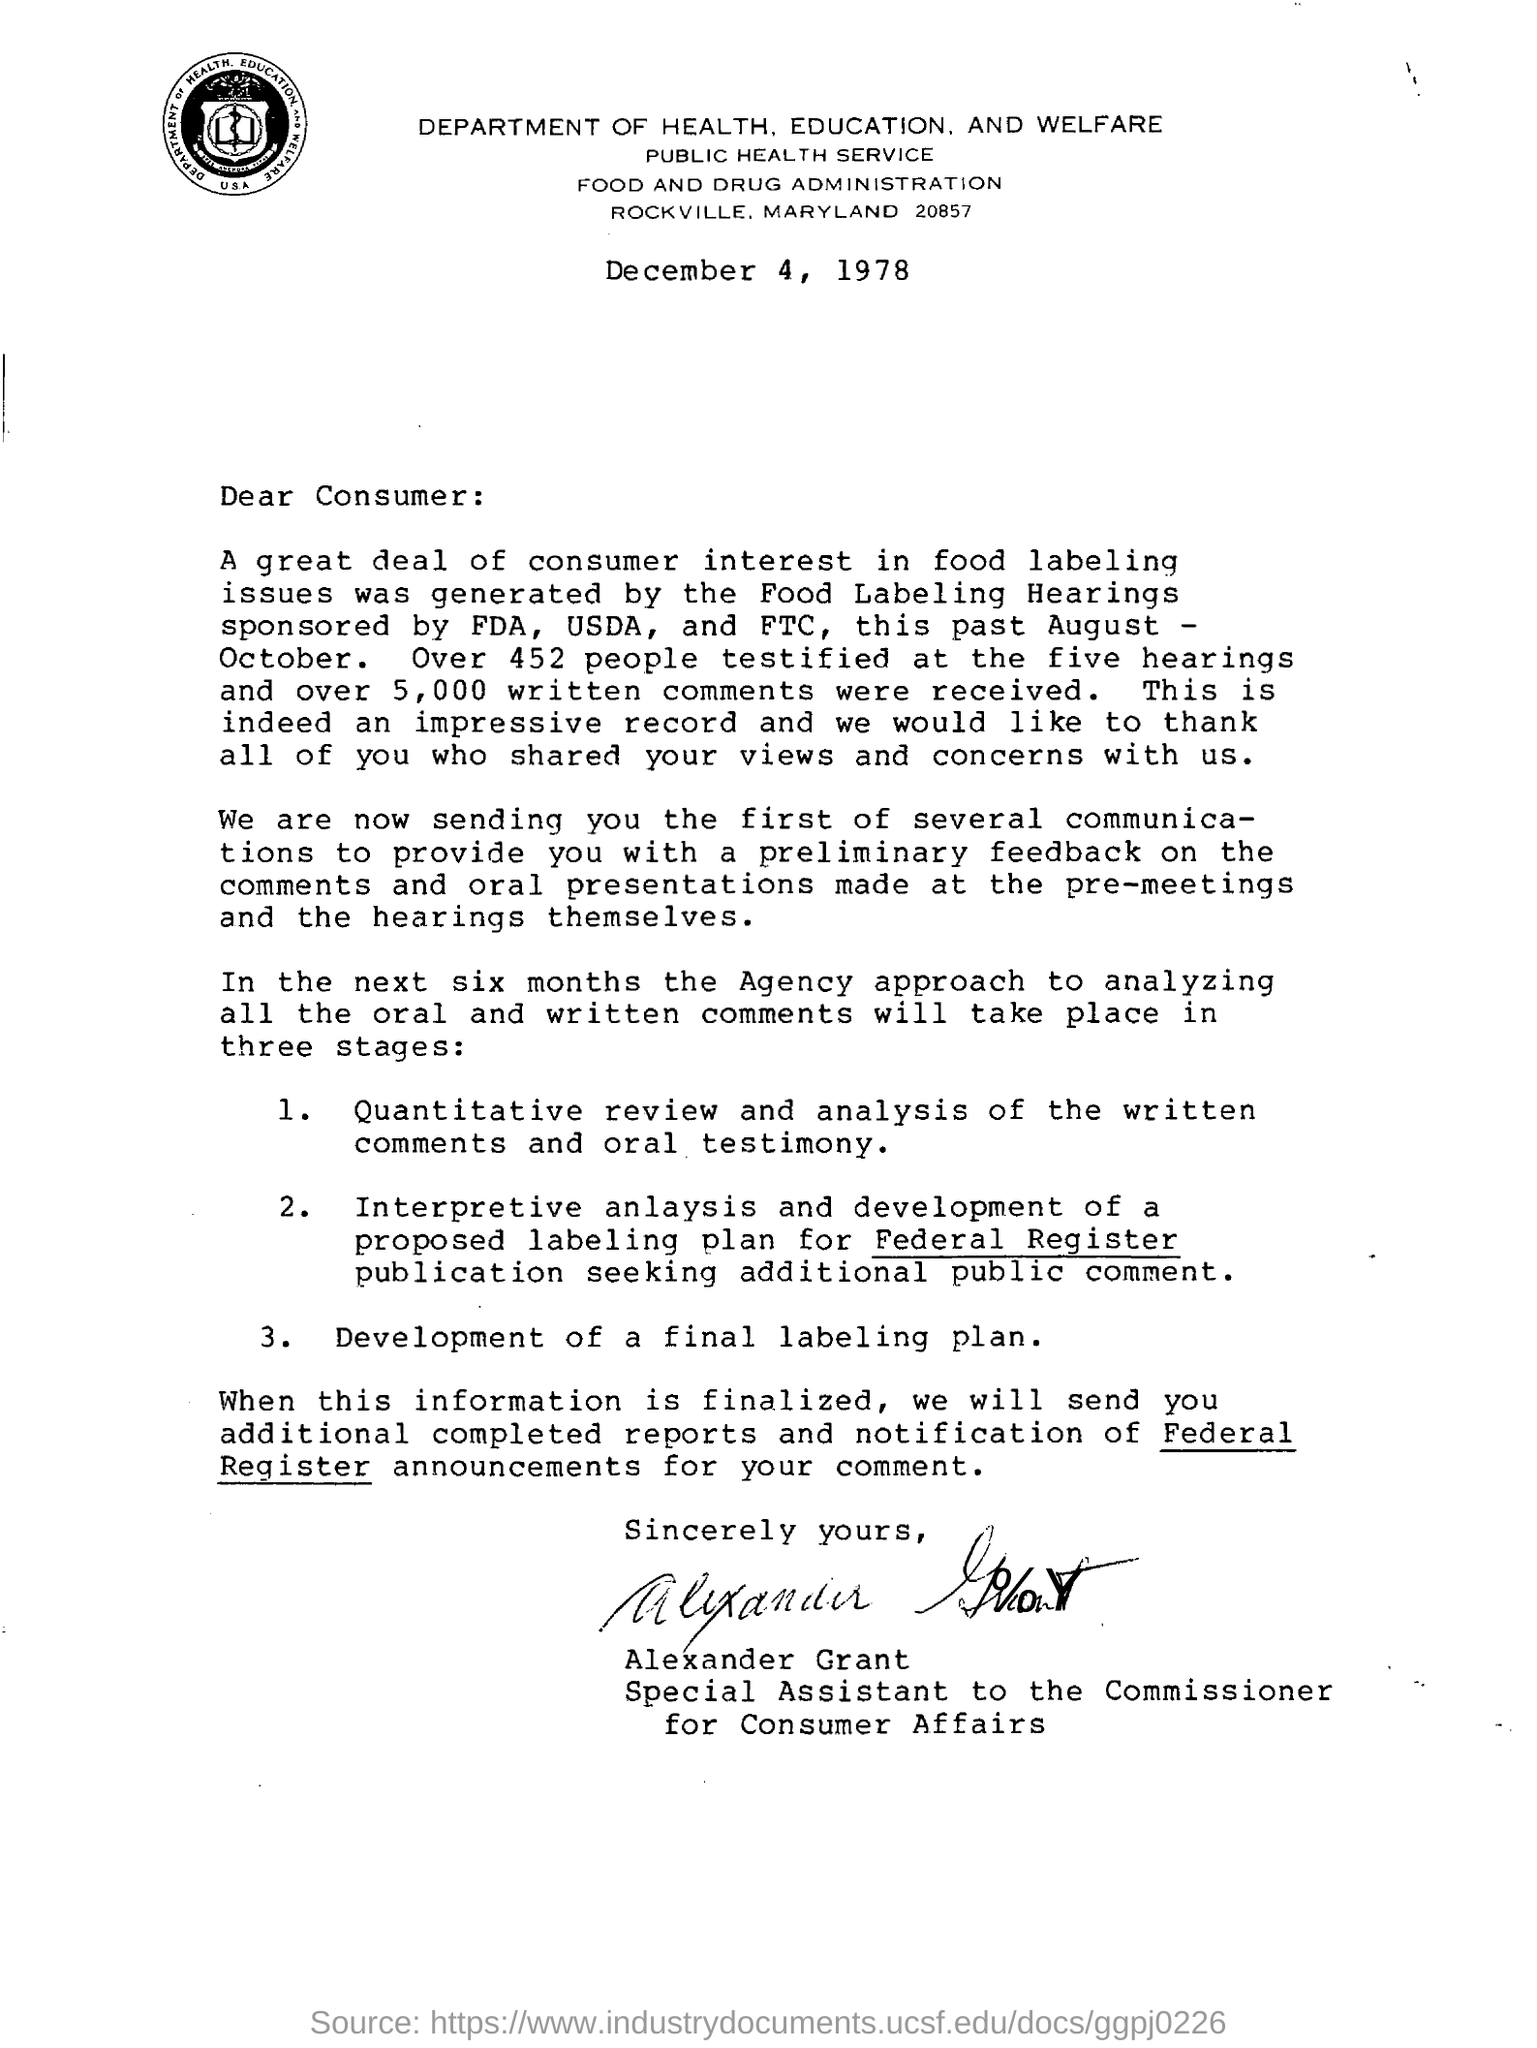From which department the letter is issued?
Provide a short and direct response. Department of health, education, and welfare. Whose signature at the bottom of page ?
Your response must be concise. Alexander Grant. 